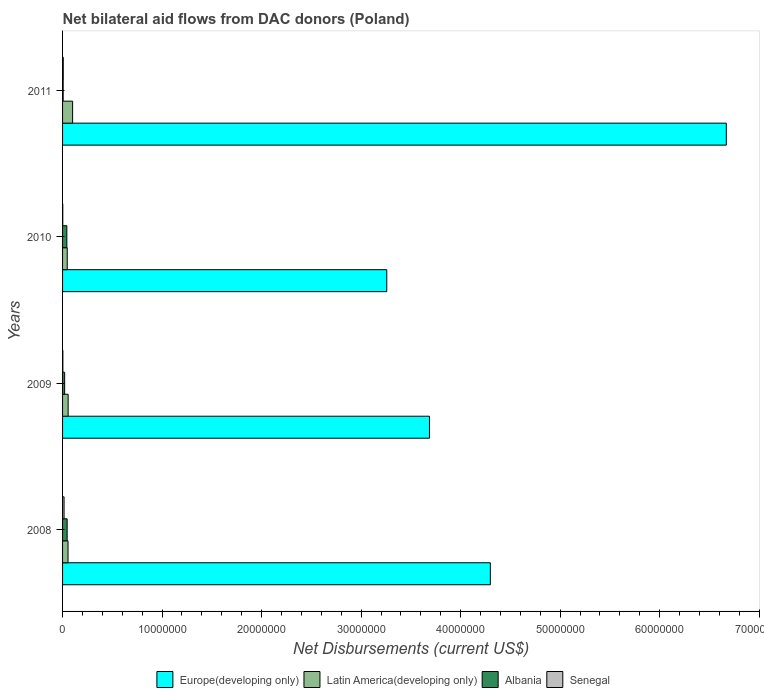How many different coloured bars are there?
Offer a very short reply. 4. How many bars are there on the 4th tick from the top?
Your answer should be very brief. 4. How many bars are there on the 4th tick from the bottom?
Give a very brief answer. 4. What is the net bilateral aid flows in Senegal in 2010?
Provide a short and direct response. 2.00e+04. Across all years, what is the maximum net bilateral aid flows in Albania?
Your answer should be compact. 4.60e+05. In which year was the net bilateral aid flows in Albania maximum?
Give a very brief answer. 2008. In which year was the net bilateral aid flows in Europe(developing only) minimum?
Provide a short and direct response. 2010. What is the total net bilateral aid flows in Albania in the graph?
Your answer should be compact. 1.16e+06. What is the difference between the net bilateral aid flows in Latin America(developing only) in 2008 and that in 2011?
Provide a succinct answer. -4.60e+05. What is the difference between the net bilateral aid flows in Latin America(developing only) in 2009 and the net bilateral aid flows in Senegal in 2011?
Your answer should be very brief. 4.90e+05. What is the average net bilateral aid flows in Europe(developing only) per year?
Provide a succinct answer. 4.48e+07. In the year 2009, what is the difference between the net bilateral aid flows in Latin America(developing only) and net bilateral aid flows in Senegal?
Make the answer very short. 5.30e+05. What is the ratio of the net bilateral aid flows in Senegal in 2009 to that in 2010?
Provide a short and direct response. 1.5. Is the difference between the net bilateral aid flows in Latin America(developing only) in 2008 and 2010 greater than the difference between the net bilateral aid flows in Senegal in 2008 and 2010?
Offer a very short reply. No. What is the difference between the highest and the second highest net bilateral aid flows in Albania?
Offer a terse response. 3.00e+04. What is the difference between the highest and the lowest net bilateral aid flows in Europe(developing only)?
Offer a terse response. 3.41e+07. Is the sum of the net bilateral aid flows in Europe(developing only) in 2009 and 2011 greater than the maximum net bilateral aid flows in Latin America(developing only) across all years?
Provide a short and direct response. Yes. Is it the case that in every year, the sum of the net bilateral aid flows in Europe(developing only) and net bilateral aid flows in Albania is greater than the sum of net bilateral aid flows in Senegal and net bilateral aid flows in Latin America(developing only)?
Your answer should be compact. Yes. What does the 2nd bar from the top in 2008 represents?
Your answer should be very brief. Albania. What does the 1st bar from the bottom in 2008 represents?
Provide a short and direct response. Europe(developing only). Are all the bars in the graph horizontal?
Provide a succinct answer. Yes. How many years are there in the graph?
Your answer should be compact. 4. Are the values on the major ticks of X-axis written in scientific E-notation?
Your answer should be very brief. No. Does the graph contain grids?
Keep it short and to the point. No. What is the title of the graph?
Make the answer very short. Net bilateral aid flows from DAC donors (Poland). Does "Papua New Guinea" appear as one of the legend labels in the graph?
Keep it short and to the point. No. What is the label or title of the X-axis?
Keep it short and to the point. Net Disbursements (current US$). What is the label or title of the Y-axis?
Ensure brevity in your answer.  Years. What is the Net Disbursements (current US$) in Europe(developing only) in 2008?
Keep it short and to the point. 4.30e+07. What is the Net Disbursements (current US$) of Latin America(developing only) in 2008?
Provide a succinct answer. 5.50e+05. What is the Net Disbursements (current US$) of Albania in 2008?
Keep it short and to the point. 4.60e+05. What is the Net Disbursements (current US$) of Senegal in 2008?
Ensure brevity in your answer.  1.50e+05. What is the Net Disbursements (current US$) in Europe(developing only) in 2009?
Provide a short and direct response. 3.69e+07. What is the Net Disbursements (current US$) in Latin America(developing only) in 2009?
Keep it short and to the point. 5.60e+05. What is the Net Disbursements (current US$) of Senegal in 2009?
Give a very brief answer. 3.00e+04. What is the Net Disbursements (current US$) of Europe(developing only) in 2010?
Ensure brevity in your answer.  3.26e+07. What is the Net Disbursements (current US$) of Albania in 2010?
Provide a succinct answer. 4.30e+05. What is the Net Disbursements (current US$) in Europe(developing only) in 2011?
Offer a very short reply. 6.67e+07. What is the Net Disbursements (current US$) in Latin America(developing only) in 2011?
Provide a short and direct response. 1.01e+06. What is the Net Disbursements (current US$) in Albania in 2011?
Make the answer very short. 6.00e+04. Across all years, what is the maximum Net Disbursements (current US$) in Europe(developing only)?
Provide a short and direct response. 6.67e+07. Across all years, what is the maximum Net Disbursements (current US$) in Latin America(developing only)?
Offer a terse response. 1.01e+06. Across all years, what is the minimum Net Disbursements (current US$) of Europe(developing only)?
Keep it short and to the point. 3.26e+07. Across all years, what is the minimum Net Disbursements (current US$) of Senegal?
Provide a short and direct response. 2.00e+04. What is the total Net Disbursements (current US$) of Europe(developing only) in the graph?
Keep it short and to the point. 1.79e+08. What is the total Net Disbursements (current US$) of Latin America(developing only) in the graph?
Give a very brief answer. 2.59e+06. What is the total Net Disbursements (current US$) of Albania in the graph?
Offer a terse response. 1.16e+06. What is the total Net Disbursements (current US$) of Senegal in the graph?
Your answer should be very brief. 2.70e+05. What is the difference between the Net Disbursements (current US$) in Europe(developing only) in 2008 and that in 2009?
Provide a short and direct response. 6.12e+06. What is the difference between the Net Disbursements (current US$) of Latin America(developing only) in 2008 and that in 2009?
Make the answer very short. -10000. What is the difference between the Net Disbursements (current US$) of Albania in 2008 and that in 2009?
Offer a very short reply. 2.50e+05. What is the difference between the Net Disbursements (current US$) in Senegal in 2008 and that in 2009?
Provide a short and direct response. 1.20e+05. What is the difference between the Net Disbursements (current US$) of Europe(developing only) in 2008 and that in 2010?
Offer a terse response. 1.04e+07. What is the difference between the Net Disbursements (current US$) of Latin America(developing only) in 2008 and that in 2010?
Offer a very short reply. 8.00e+04. What is the difference between the Net Disbursements (current US$) in Albania in 2008 and that in 2010?
Keep it short and to the point. 3.00e+04. What is the difference between the Net Disbursements (current US$) of Senegal in 2008 and that in 2010?
Your response must be concise. 1.30e+05. What is the difference between the Net Disbursements (current US$) in Europe(developing only) in 2008 and that in 2011?
Provide a succinct answer. -2.37e+07. What is the difference between the Net Disbursements (current US$) of Latin America(developing only) in 2008 and that in 2011?
Offer a terse response. -4.60e+05. What is the difference between the Net Disbursements (current US$) of Albania in 2008 and that in 2011?
Offer a terse response. 4.00e+05. What is the difference between the Net Disbursements (current US$) of Senegal in 2008 and that in 2011?
Keep it short and to the point. 8.00e+04. What is the difference between the Net Disbursements (current US$) of Europe(developing only) in 2009 and that in 2010?
Provide a succinct answer. 4.29e+06. What is the difference between the Net Disbursements (current US$) of Senegal in 2009 and that in 2010?
Keep it short and to the point. 10000. What is the difference between the Net Disbursements (current US$) of Europe(developing only) in 2009 and that in 2011?
Make the answer very short. -2.98e+07. What is the difference between the Net Disbursements (current US$) in Latin America(developing only) in 2009 and that in 2011?
Give a very brief answer. -4.50e+05. What is the difference between the Net Disbursements (current US$) of Senegal in 2009 and that in 2011?
Ensure brevity in your answer.  -4.00e+04. What is the difference between the Net Disbursements (current US$) in Europe(developing only) in 2010 and that in 2011?
Your response must be concise. -3.41e+07. What is the difference between the Net Disbursements (current US$) of Latin America(developing only) in 2010 and that in 2011?
Provide a succinct answer. -5.40e+05. What is the difference between the Net Disbursements (current US$) of Albania in 2010 and that in 2011?
Keep it short and to the point. 3.70e+05. What is the difference between the Net Disbursements (current US$) in Senegal in 2010 and that in 2011?
Make the answer very short. -5.00e+04. What is the difference between the Net Disbursements (current US$) of Europe(developing only) in 2008 and the Net Disbursements (current US$) of Latin America(developing only) in 2009?
Give a very brief answer. 4.24e+07. What is the difference between the Net Disbursements (current US$) in Europe(developing only) in 2008 and the Net Disbursements (current US$) in Albania in 2009?
Offer a terse response. 4.28e+07. What is the difference between the Net Disbursements (current US$) of Europe(developing only) in 2008 and the Net Disbursements (current US$) of Senegal in 2009?
Offer a terse response. 4.30e+07. What is the difference between the Net Disbursements (current US$) in Latin America(developing only) in 2008 and the Net Disbursements (current US$) in Senegal in 2009?
Make the answer very short. 5.20e+05. What is the difference between the Net Disbursements (current US$) of Europe(developing only) in 2008 and the Net Disbursements (current US$) of Latin America(developing only) in 2010?
Your response must be concise. 4.25e+07. What is the difference between the Net Disbursements (current US$) in Europe(developing only) in 2008 and the Net Disbursements (current US$) in Albania in 2010?
Provide a short and direct response. 4.26e+07. What is the difference between the Net Disbursements (current US$) of Europe(developing only) in 2008 and the Net Disbursements (current US$) of Senegal in 2010?
Your answer should be compact. 4.30e+07. What is the difference between the Net Disbursements (current US$) in Latin America(developing only) in 2008 and the Net Disbursements (current US$) in Senegal in 2010?
Offer a very short reply. 5.30e+05. What is the difference between the Net Disbursements (current US$) of Europe(developing only) in 2008 and the Net Disbursements (current US$) of Latin America(developing only) in 2011?
Keep it short and to the point. 4.20e+07. What is the difference between the Net Disbursements (current US$) of Europe(developing only) in 2008 and the Net Disbursements (current US$) of Albania in 2011?
Provide a succinct answer. 4.29e+07. What is the difference between the Net Disbursements (current US$) in Europe(developing only) in 2008 and the Net Disbursements (current US$) in Senegal in 2011?
Ensure brevity in your answer.  4.29e+07. What is the difference between the Net Disbursements (current US$) in Latin America(developing only) in 2008 and the Net Disbursements (current US$) in Albania in 2011?
Your answer should be very brief. 4.90e+05. What is the difference between the Net Disbursements (current US$) of Latin America(developing only) in 2008 and the Net Disbursements (current US$) of Senegal in 2011?
Offer a very short reply. 4.80e+05. What is the difference between the Net Disbursements (current US$) in Albania in 2008 and the Net Disbursements (current US$) in Senegal in 2011?
Provide a short and direct response. 3.90e+05. What is the difference between the Net Disbursements (current US$) in Europe(developing only) in 2009 and the Net Disbursements (current US$) in Latin America(developing only) in 2010?
Make the answer very short. 3.64e+07. What is the difference between the Net Disbursements (current US$) in Europe(developing only) in 2009 and the Net Disbursements (current US$) in Albania in 2010?
Keep it short and to the point. 3.64e+07. What is the difference between the Net Disbursements (current US$) of Europe(developing only) in 2009 and the Net Disbursements (current US$) of Senegal in 2010?
Offer a terse response. 3.68e+07. What is the difference between the Net Disbursements (current US$) of Latin America(developing only) in 2009 and the Net Disbursements (current US$) of Albania in 2010?
Offer a terse response. 1.30e+05. What is the difference between the Net Disbursements (current US$) in Latin America(developing only) in 2009 and the Net Disbursements (current US$) in Senegal in 2010?
Make the answer very short. 5.40e+05. What is the difference between the Net Disbursements (current US$) in Albania in 2009 and the Net Disbursements (current US$) in Senegal in 2010?
Offer a very short reply. 1.90e+05. What is the difference between the Net Disbursements (current US$) in Europe(developing only) in 2009 and the Net Disbursements (current US$) in Latin America(developing only) in 2011?
Make the answer very short. 3.59e+07. What is the difference between the Net Disbursements (current US$) of Europe(developing only) in 2009 and the Net Disbursements (current US$) of Albania in 2011?
Your answer should be very brief. 3.68e+07. What is the difference between the Net Disbursements (current US$) in Europe(developing only) in 2009 and the Net Disbursements (current US$) in Senegal in 2011?
Offer a terse response. 3.68e+07. What is the difference between the Net Disbursements (current US$) in Albania in 2009 and the Net Disbursements (current US$) in Senegal in 2011?
Give a very brief answer. 1.40e+05. What is the difference between the Net Disbursements (current US$) of Europe(developing only) in 2010 and the Net Disbursements (current US$) of Latin America(developing only) in 2011?
Provide a short and direct response. 3.16e+07. What is the difference between the Net Disbursements (current US$) in Europe(developing only) in 2010 and the Net Disbursements (current US$) in Albania in 2011?
Provide a short and direct response. 3.25e+07. What is the difference between the Net Disbursements (current US$) in Europe(developing only) in 2010 and the Net Disbursements (current US$) in Senegal in 2011?
Your answer should be compact. 3.25e+07. What is the difference between the Net Disbursements (current US$) in Albania in 2010 and the Net Disbursements (current US$) in Senegal in 2011?
Offer a terse response. 3.60e+05. What is the average Net Disbursements (current US$) in Europe(developing only) per year?
Your answer should be very brief. 4.48e+07. What is the average Net Disbursements (current US$) of Latin America(developing only) per year?
Keep it short and to the point. 6.48e+05. What is the average Net Disbursements (current US$) of Albania per year?
Keep it short and to the point. 2.90e+05. What is the average Net Disbursements (current US$) of Senegal per year?
Provide a succinct answer. 6.75e+04. In the year 2008, what is the difference between the Net Disbursements (current US$) of Europe(developing only) and Net Disbursements (current US$) of Latin America(developing only)?
Keep it short and to the point. 4.24e+07. In the year 2008, what is the difference between the Net Disbursements (current US$) in Europe(developing only) and Net Disbursements (current US$) in Albania?
Offer a very short reply. 4.25e+07. In the year 2008, what is the difference between the Net Disbursements (current US$) in Europe(developing only) and Net Disbursements (current US$) in Senegal?
Your answer should be very brief. 4.28e+07. In the year 2008, what is the difference between the Net Disbursements (current US$) in Latin America(developing only) and Net Disbursements (current US$) in Albania?
Your answer should be very brief. 9.00e+04. In the year 2008, what is the difference between the Net Disbursements (current US$) of Latin America(developing only) and Net Disbursements (current US$) of Senegal?
Provide a short and direct response. 4.00e+05. In the year 2008, what is the difference between the Net Disbursements (current US$) in Albania and Net Disbursements (current US$) in Senegal?
Give a very brief answer. 3.10e+05. In the year 2009, what is the difference between the Net Disbursements (current US$) of Europe(developing only) and Net Disbursements (current US$) of Latin America(developing only)?
Your answer should be very brief. 3.63e+07. In the year 2009, what is the difference between the Net Disbursements (current US$) of Europe(developing only) and Net Disbursements (current US$) of Albania?
Give a very brief answer. 3.67e+07. In the year 2009, what is the difference between the Net Disbursements (current US$) in Europe(developing only) and Net Disbursements (current US$) in Senegal?
Give a very brief answer. 3.68e+07. In the year 2009, what is the difference between the Net Disbursements (current US$) of Latin America(developing only) and Net Disbursements (current US$) of Senegal?
Your answer should be compact. 5.30e+05. In the year 2010, what is the difference between the Net Disbursements (current US$) of Europe(developing only) and Net Disbursements (current US$) of Latin America(developing only)?
Ensure brevity in your answer.  3.21e+07. In the year 2010, what is the difference between the Net Disbursements (current US$) of Europe(developing only) and Net Disbursements (current US$) of Albania?
Offer a very short reply. 3.22e+07. In the year 2010, what is the difference between the Net Disbursements (current US$) in Europe(developing only) and Net Disbursements (current US$) in Senegal?
Keep it short and to the point. 3.26e+07. In the year 2010, what is the difference between the Net Disbursements (current US$) in Latin America(developing only) and Net Disbursements (current US$) in Senegal?
Provide a succinct answer. 4.50e+05. In the year 2010, what is the difference between the Net Disbursements (current US$) of Albania and Net Disbursements (current US$) of Senegal?
Provide a short and direct response. 4.10e+05. In the year 2011, what is the difference between the Net Disbursements (current US$) in Europe(developing only) and Net Disbursements (current US$) in Latin America(developing only)?
Your answer should be compact. 6.57e+07. In the year 2011, what is the difference between the Net Disbursements (current US$) in Europe(developing only) and Net Disbursements (current US$) in Albania?
Your answer should be very brief. 6.66e+07. In the year 2011, what is the difference between the Net Disbursements (current US$) in Europe(developing only) and Net Disbursements (current US$) in Senegal?
Ensure brevity in your answer.  6.66e+07. In the year 2011, what is the difference between the Net Disbursements (current US$) in Latin America(developing only) and Net Disbursements (current US$) in Albania?
Provide a short and direct response. 9.50e+05. In the year 2011, what is the difference between the Net Disbursements (current US$) of Latin America(developing only) and Net Disbursements (current US$) of Senegal?
Offer a very short reply. 9.40e+05. What is the ratio of the Net Disbursements (current US$) in Europe(developing only) in 2008 to that in 2009?
Provide a succinct answer. 1.17. What is the ratio of the Net Disbursements (current US$) in Latin America(developing only) in 2008 to that in 2009?
Give a very brief answer. 0.98. What is the ratio of the Net Disbursements (current US$) in Albania in 2008 to that in 2009?
Make the answer very short. 2.19. What is the ratio of the Net Disbursements (current US$) in Europe(developing only) in 2008 to that in 2010?
Provide a succinct answer. 1.32. What is the ratio of the Net Disbursements (current US$) of Latin America(developing only) in 2008 to that in 2010?
Provide a succinct answer. 1.17. What is the ratio of the Net Disbursements (current US$) of Albania in 2008 to that in 2010?
Offer a terse response. 1.07. What is the ratio of the Net Disbursements (current US$) in Senegal in 2008 to that in 2010?
Your response must be concise. 7.5. What is the ratio of the Net Disbursements (current US$) of Europe(developing only) in 2008 to that in 2011?
Your response must be concise. 0.64. What is the ratio of the Net Disbursements (current US$) in Latin America(developing only) in 2008 to that in 2011?
Make the answer very short. 0.54. What is the ratio of the Net Disbursements (current US$) in Albania in 2008 to that in 2011?
Provide a short and direct response. 7.67. What is the ratio of the Net Disbursements (current US$) in Senegal in 2008 to that in 2011?
Keep it short and to the point. 2.14. What is the ratio of the Net Disbursements (current US$) in Europe(developing only) in 2009 to that in 2010?
Give a very brief answer. 1.13. What is the ratio of the Net Disbursements (current US$) in Latin America(developing only) in 2009 to that in 2010?
Give a very brief answer. 1.19. What is the ratio of the Net Disbursements (current US$) of Albania in 2009 to that in 2010?
Offer a terse response. 0.49. What is the ratio of the Net Disbursements (current US$) of Senegal in 2009 to that in 2010?
Provide a succinct answer. 1.5. What is the ratio of the Net Disbursements (current US$) in Europe(developing only) in 2009 to that in 2011?
Give a very brief answer. 0.55. What is the ratio of the Net Disbursements (current US$) in Latin America(developing only) in 2009 to that in 2011?
Provide a succinct answer. 0.55. What is the ratio of the Net Disbursements (current US$) in Albania in 2009 to that in 2011?
Your answer should be compact. 3.5. What is the ratio of the Net Disbursements (current US$) in Senegal in 2009 to that in 2011?
Ensure brevity in your answer.  0.43. What is the ratio of the Net Disbursements (current US$) of Europe(developing only) in 2010 to that in 2011?
Your response must be concise. 0.49. What is the ratio of the Net Disbursements (current US$) of Latin America(developing only) in 2010 to that in 2011?
Provide a succinct answer. 0.47. What is the ratio of the Net Disbursements (current US$) in Albania in 2010 to that in 2011?
Ensure brevity in your answer.  7.17. What is the ratio of the Net Disbursements (current US$) of Senegal in 2010 to that in 2011?
Make the answer very short. 0.29. What is the difference between the highest and the second highest Net Disbursements (current US$) in Europe(developing only)?
Provide a succinct answer. 2.37e+07. What is the difference between the highest and the second highest Net Disbursements (current US$) of Albania?
Ensure brevity in your answer.  3.00e+04. What is the difference between the highest and the second highest Net Disbursements (current US$) of Senegal?
Make the answer very short. 8.00e+04. What is the difference between the highest and the lowest Net Disbursements (current US$) of Europe(developing only)?
Your response must be concise. 3.41e+07. What is the difference between the highest and the lowest Net Disbursements (current US$) in Latin America(developing only)?
Provide a succinct answer. 5.40e+05. What is the difference between the highest and the lowest Net Disbursements (current US$) of Albania?
Your response must be concise. 4.00e+05. What is the difference between the highest and the lowest Net Disbursements (current US$) in Senegal?
Your answer should be very brief. 1.30e+05. 